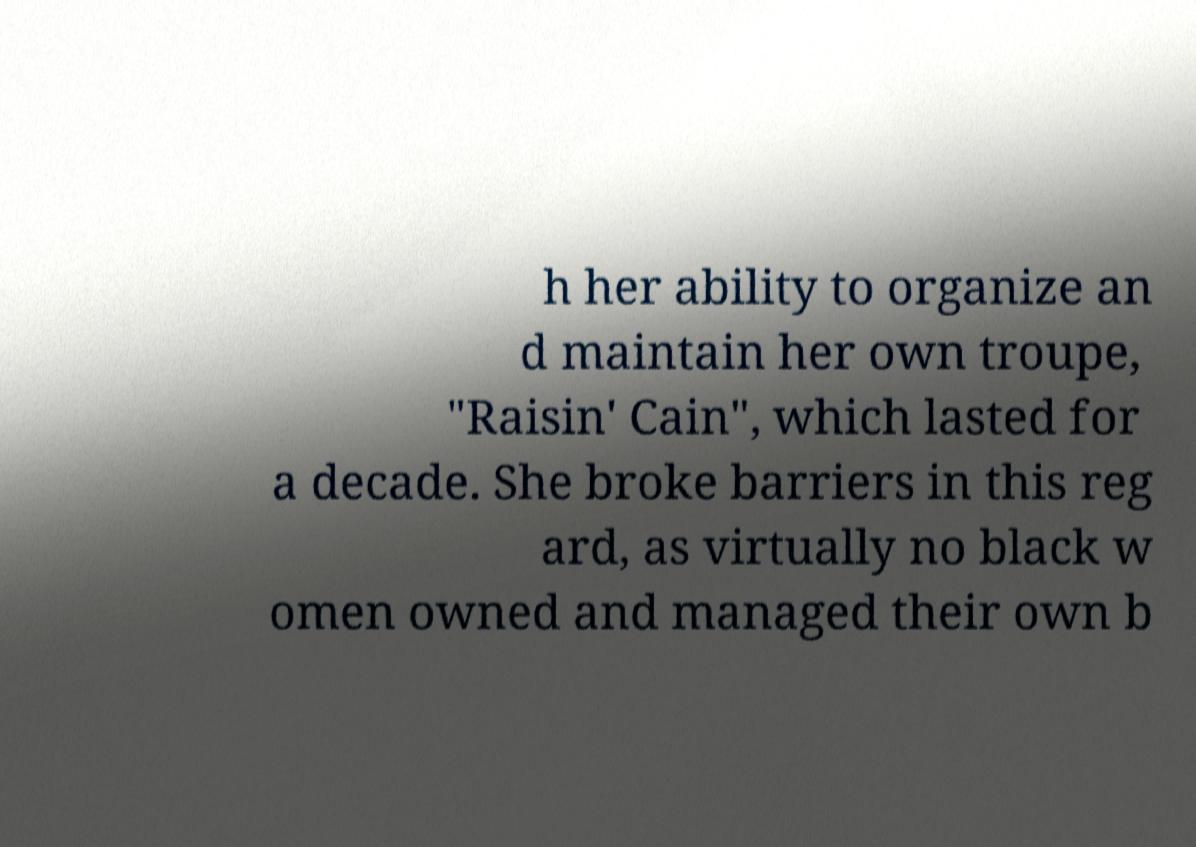Can you accurately transcribe the text from the provided image for me? h her ability to organize an d maintain her own troupe, "Raisin' Cain", which lasted for a decade. She broke barriers in this reg ard, as virtually no black w omen owned and managed their own b 